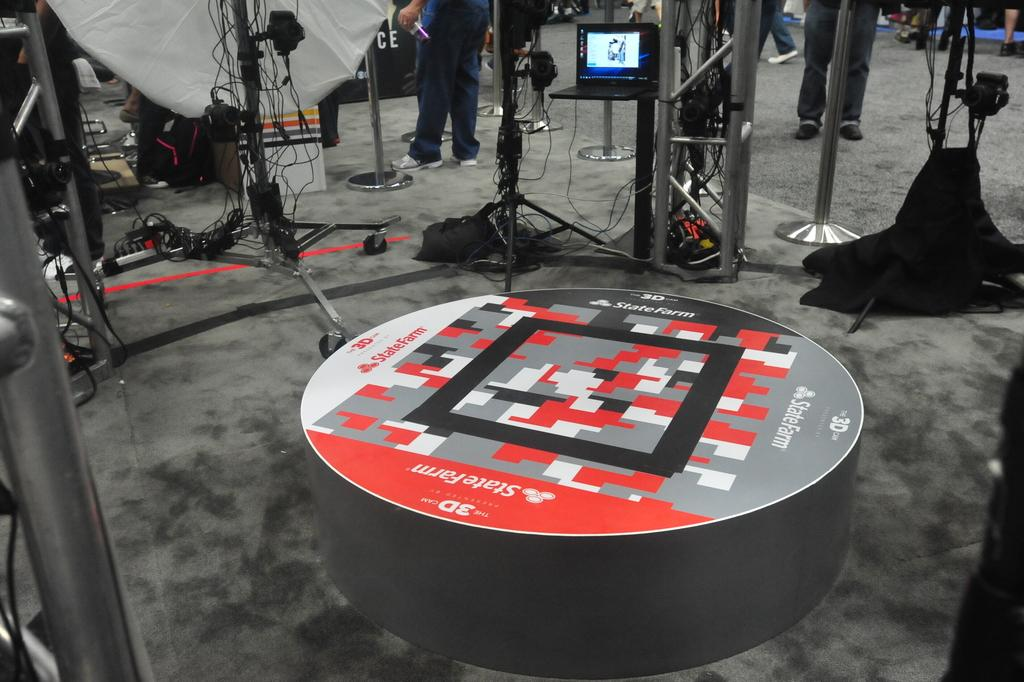What is the shape of the object at the bottom of the image? The object at the bottom of the image is round shaped. What can be seen in the image besides the round shaped object? There are poles of cameras in the image. Where are the persons located in the image? The persons are standing at the top of the image. What is the opinion of the oranges about the round shaped object in the image? There are no oranges present in the image, so it is not possible to determine their opinion about the round shaped object. 